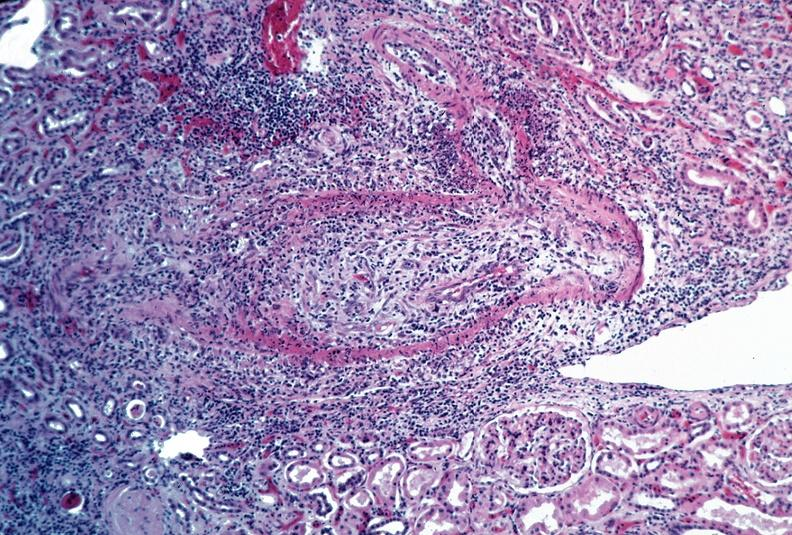s vasculature present?
Answer the question using a single word or phrase. Yes 